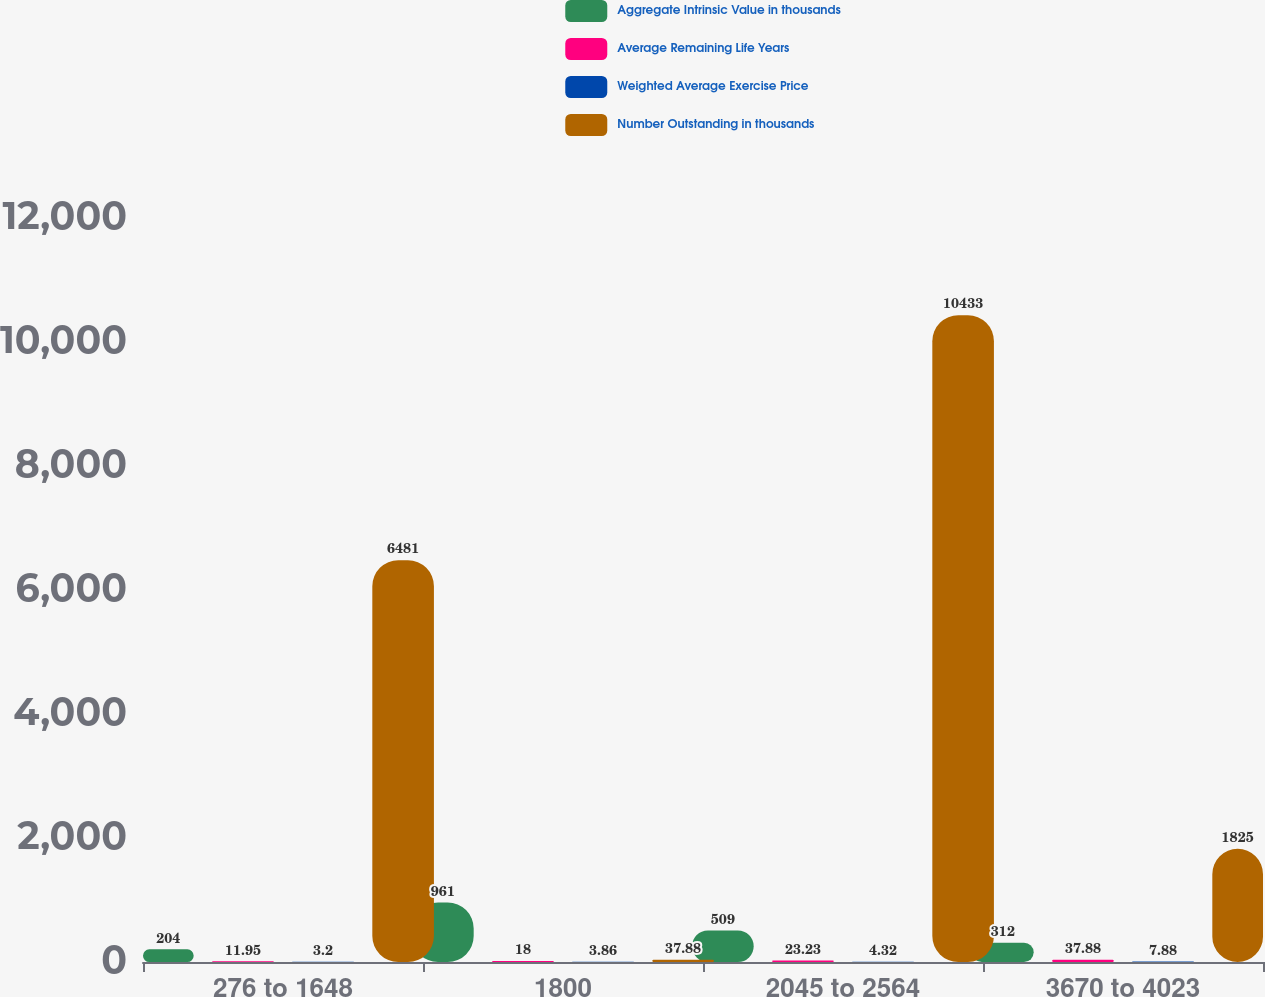Convert chart. <chart><loc_0><loc_0><loc_500><loc_500><stacked_bar_chart><ecel><fcel>276 to 1648<fcel>1800<fcel>2045 to 2564<fcel>3670 to 4023<nl><fcel>Aggregate Intrinsic Value in thousands<fcel>204<fcel>961<fcel>509<fcel>312<nl><fcel>Average Remaining Life Years<fcel>11.95<fcel>18<fcel>23.23<fcel>37.88<nl><fcel>Weighted Average Exercise Price<fcel>3.2<fcel>3.86<fcel>4.32<fcel>7.88<nl><fcel>Number Outstanding in thousands<fcel>6481<fcel>37.88<fcel>10433<fcel>1825<nl></chart> 